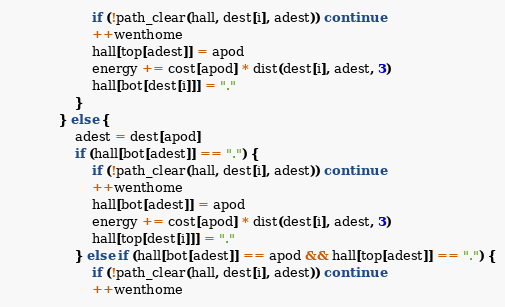<code> <loc_0><loc_0><loc_500><loc_500><_Awk_>                    if (!path_clear(hall, dest[i], adest)) continue
                    ++wenthome
                    hall[top[adest]] = apod
                    energy += cost[apod] * dist(dest[i], adest, 3)
                    hall[bot[dest[i]]] = "."
                }
            } else {
                adest = dest[apod]
                if (hall[bot[adest]] == ".") {
                    if (!path_clear(hall, dest[i], adest)) continue
                    ++wenthome
                    hall[bot[adest]] = apod
                    energy += cost[apod] * dist(dest[i], adest, 3)
                    hall[top[dest[i]]] = "."
                } else if (hall[bot[adest]] == apod && hall[top[adest]] == ".") {
                    if (!path_clear(hall, dest[i], adest)) continue
                    ++wenthome</code> 